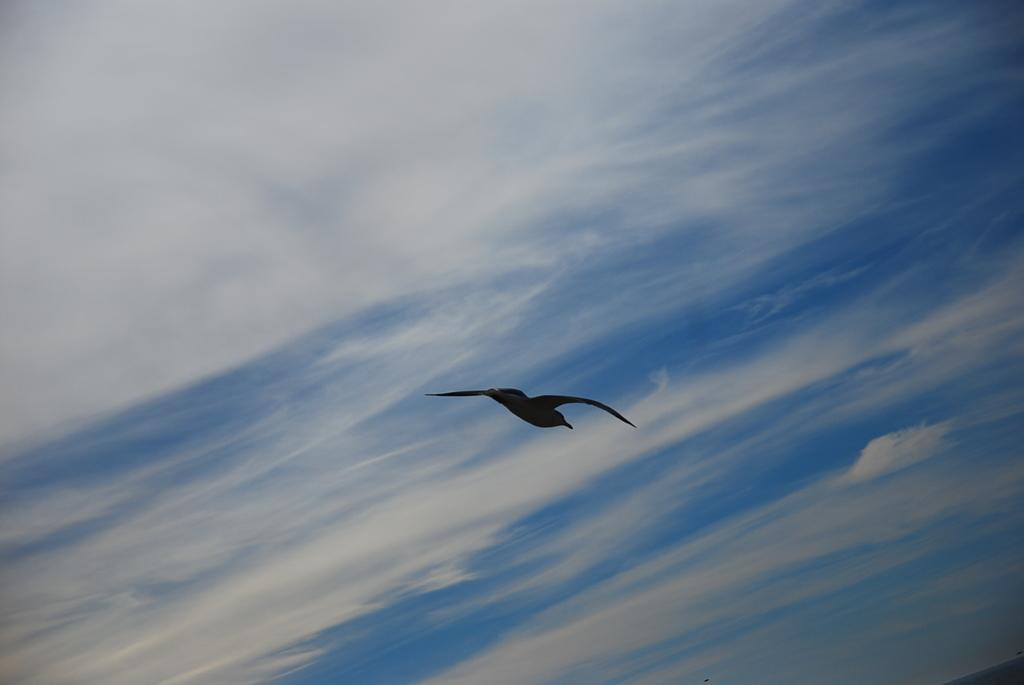What type of animal can be seen in the image? There is a bird in the image. What is visible in the background of the image? The sky is visible in the image. What can be observed in the sky? There are clouds in the sky. How many geese are present in the room in the image? There is no room or geese present in the image; it features a bird and the sky with clouds. What type of creature is interacting with the bird in the image? There is no creature interacting with the bird in the image; only the bird and the sky with clouds are present. 